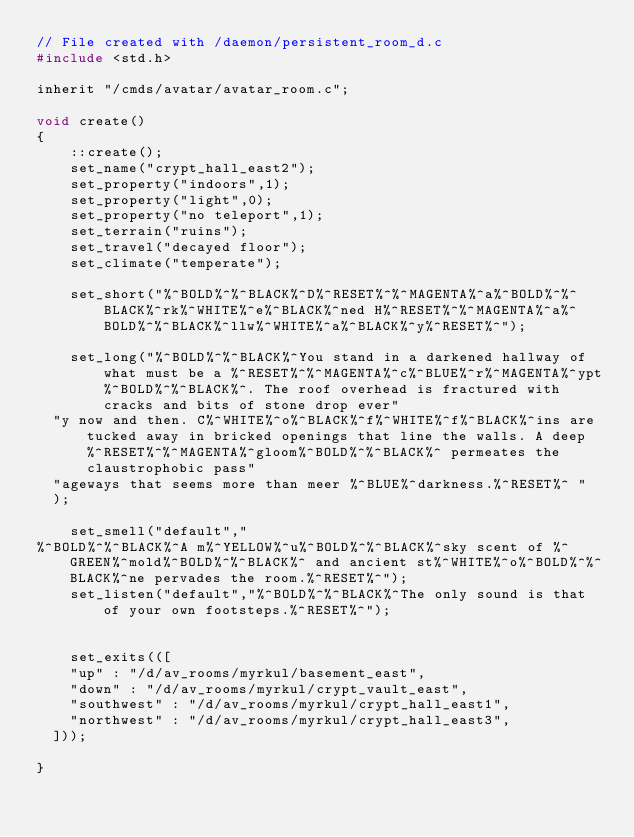<code> <loc_0><loc_0><loc_500><loc_500><_C_>// File created with /daemon/persistent_room_d.c
#include <std.h>

inherit "/cmds/avatar/avatar_room.c";

void create()
{
    ::create();
    set_name("crypt_hall_east2");
    set_property("indoors",1);
    set_property("light",0);
    set_property("no teleport",1);
    set_terrain("ruins");
    set_travel("decayed floor");
    set_climate("temperate");

    set_short("%^BOLD%^%^BLACK%^D%^RESET%^%^MAGENTA%^a%^BOLD%^%^BLACK%^rk%^WHITE%^e%^BLACK%^ned H%^RESET%^%^MAGENTA%^a%^BOLD%^%^BLACK%^llw%^WHITE%^a%^BLACK%^y%^RESET%^");

    set_long("%^BOLD%^%^BLACK%^You stand in a darkened hallway of what must be a %^RESET%^%^MAGENTA%^c%^BLUE%^r%^MAGENTA%^ypt%^BOLD%^%^BLACK%^. The roof overhead is fractured with cracks and bits of stone drop ever"
	"y now and then. C%^WHITE%^o%^BLACK%^f%^WHITE%^f%^BLACK%^ins are tucked away in bricked openings that line the walls. A deep %^RESET%^%^MAGENTA%^gloom%^BOLD%^%^BLACK%^ permeates the claustrophobic pass"
	"ageways that seems more than meer %^BLUE%^darkness.%^RESET%^ "
	);

    set_smell("default","
%^BOLD%^%^BLACK%^A m%^YELLOW%^u%^BOLD%^%^BLACK%^sky scent of %^GREEN%^mold%^BOLD%^%^BLACK%^ and ancient st%^WHITE%^o%^BOLD%^%^BLACK%^ne pervades the room.%^RESET%^");
    set_listen("default","%^BOLD%^%^BLACK%^The only sound is that of your own footsteps.%^RESET%^");


    set_exits(([ 
		"up" : "/d/av_rooms/myrkul/basement_east",
		"down" : "/d/av_rooms/myrkul/crypt_vault_east",
		"southwest" : "/d/av_rooms/myrkul/crypt_hall_east1",
		"northwest" : "/d/av_rooms/myrkul/crypt_hall_east3",
	]));

}</code> 